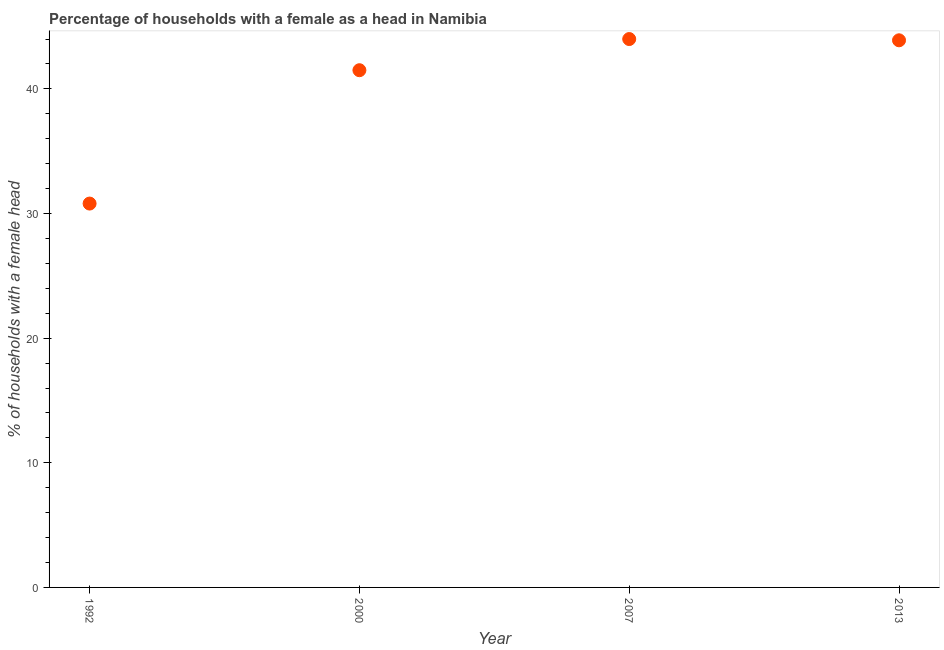What is the number of female supervised households in 1992?
Provide a short and direct response. 30.8. Across all years, what is the minimum number of female supervised households?
Make the answer very short. 30.8. What is the sum of the number of female supervised households?
Offer a very short reply. 160.2. What is the difference between the number of female supervised households in 1992 and 2000?
Make the answer very short. -10.7. What is the average number of female supervised households per year?
Offer a very short reply. 40.05. What is the median number of female supervised households?
Provide a succinct answer. 42.7. In how many years, is the number of female supervised households greater than 2 %?
Offer a terse response. 4. Do a majority of the years between 1992 and 2013 (inclusive) have number of female supervised households greater than 20 %?
Ensure brevity in your answer.  Yes. What is the ratio of the number of female supervised households in 1992 to that in 2013?
Ensure brevity in your answer.  0.7. Is the number of female supervised households in 2000 less than that in 2007?
Offer a very short reply. Yes. Is the difference between the number of female supervised households in 1992 and 2013 greater than the difference between any two years?
Your response must be concise. No. What is the difference between the highest and the second highest number of female supervised households?
Ensure brevity in your answer.  0.1. What is the difference between the highest and the lowest number of female supervised households?
Offer a terse response. 13.2. In how many years, is the number of female supervised households greater than the average number of female supervised households taken over all years?
Offer a terse response. 3. Does the number of female supervised households monotonically increase over the years?
Give a very brief answer. No. How many dotlines are there?
Your response must be concise. 1. How many years are there in the graph?
Your answer should be compact. 4. Are the values on the major ticks of Y-axis written in scientific E-notation?
Provide a short and direct response. No. Does the graph contain any zero values?
Offer a terse response. No. What is the title of the graph?
Make the answer very short. Percentage of households with a female as a head in Namibia. What is the label or title of the X-axis?
Your response must be concise. Year. What is the label or title of the Y-axis?
Make the answer very short. % of households with a female head. What is the % of households with a female head in 1992?
Ensure brevity in your answer.  30.8. What is the % of households with a female head in 2000?
Your answer should be compact. 41.5. What is the % of households with a female head in 2013?
Give a very brief answer. 43.9. What is the difference between the % of households with a female head in 2000 and 2007?
Provide a short and direct response. -2.5. What is the ratio of the % of households with a female head in 1992 to that in 2000?
Make the answer very short. 0.74. What is the ratio of the % of households with a female head in 1992 to that in 2007?
Your answer should be compact. 0.7. What is the ratio of the % of households with a female head in 1992 to that in 2013?
Your response must be concise. 0.7. What is the ratio of the % of households with a female head in 2000 to that in 2007?
Your answer should be compact. 0.94. What is the ratio of the % of households with a female head in 2000 to that in 2013?
Your response must be concise. 0.94. What is the ratio of the % of households with a female head in 2007 to that in 2013?
Give a very brief answer. 1. 